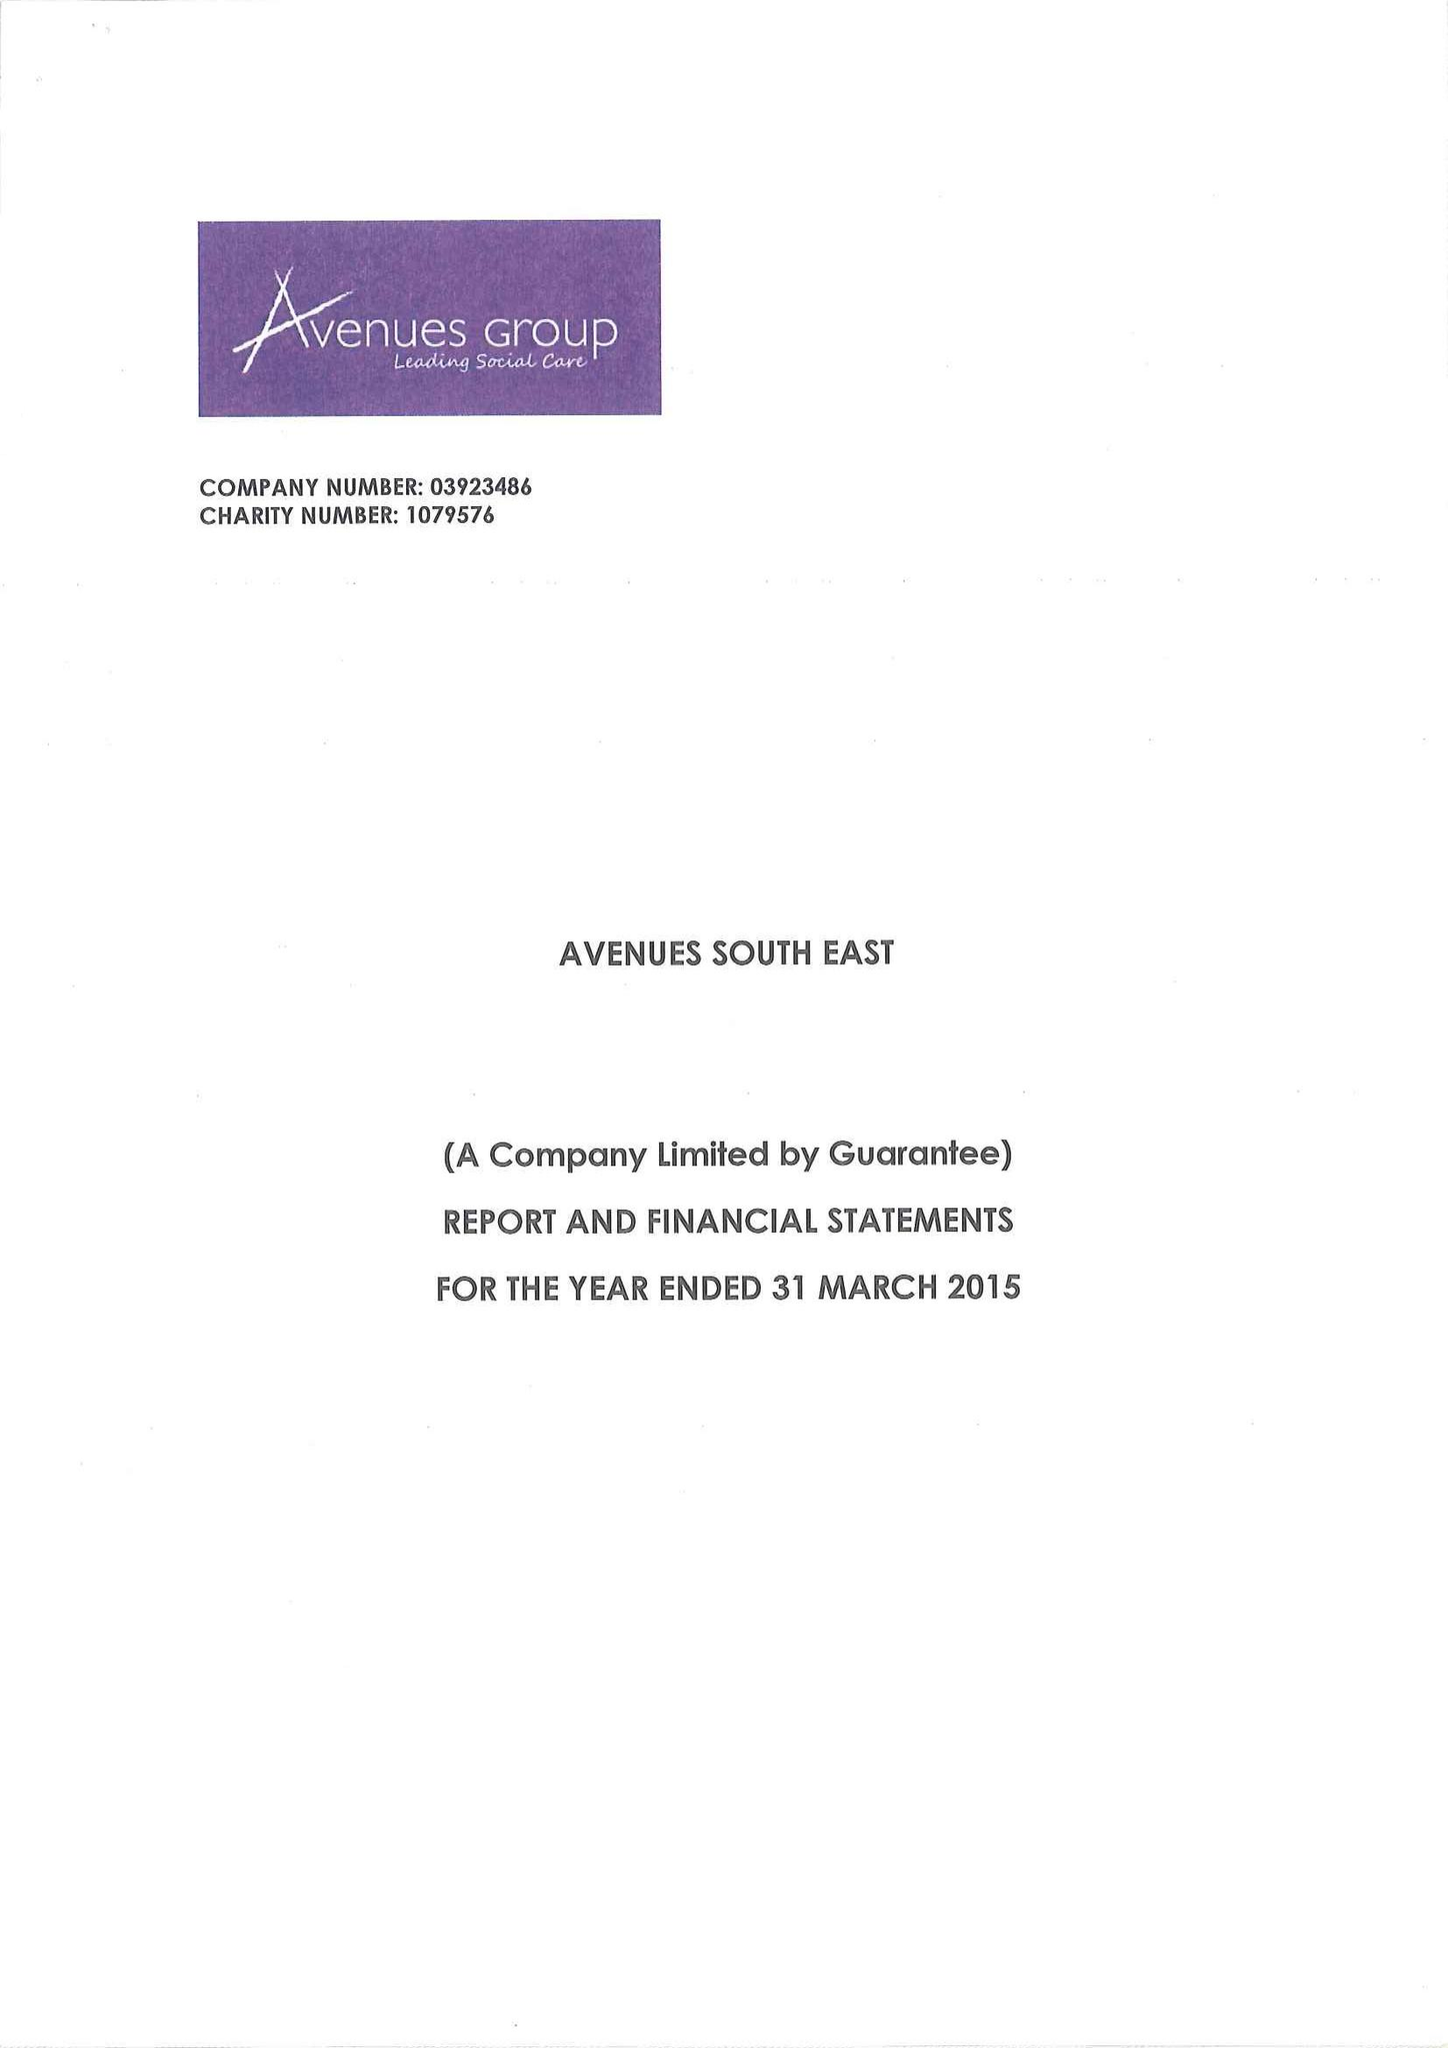What is the value for the address__post_town?
Answer the question using a single word or phrase. SIDCUP 